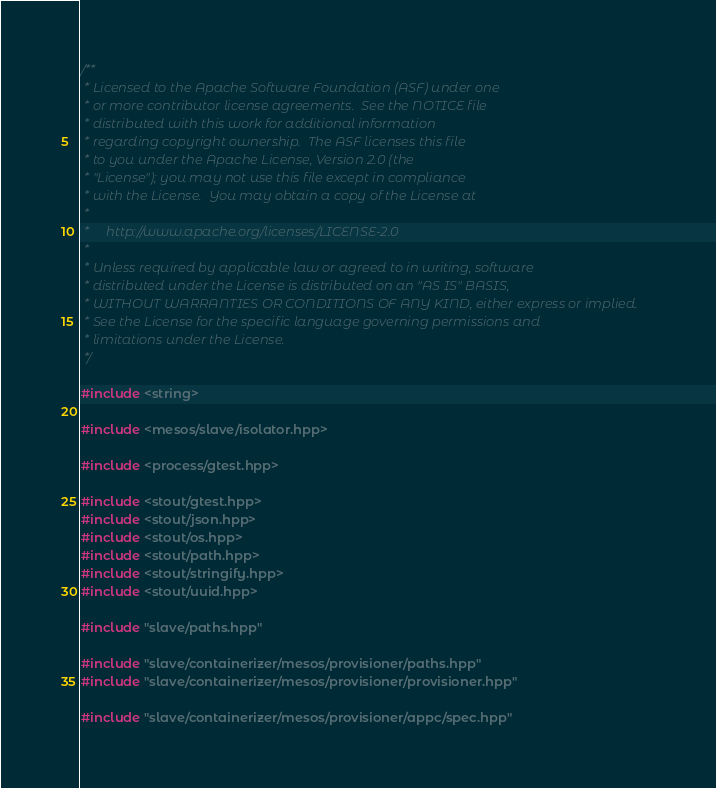<code> <loc_0><loc_0><loc_500><loc_500><_C++_>/**
 * Licensed to the Apache Software Foundation (ASF) under one
 * or more contributor license agreements.  See the NOTICE file
 * distributed with this work for additional information
 * regarding copyright ownership.  The ASF licenses this file
 * to you under the Apache License, Version 2.0 (the
 * "License"); you may not use this file except in compliance
 * with the License.  You may obtain a copy of the License at
 *
 *     http://www.apache.org/licenses/LICENSE-2.0
 *
 * Unless required by applicable law or agreed to in writing, software
 * distributed under the License is distributed on an "AS IS" BASIS,
 * WITHOUT WARRANTIES OR CONDITIONS OF ANY KIND, either express or implied.
 * See the License for the specific language governing permissions and
 * limitations under the License.
 */

#include <string>

#include <mesos/slave/isolator.hpp>

#include <process/gtest.hpp>

#include <stout/gtest.hpp>
#include <stout/json.hpp>
#include <stout/os.hpp>
#include <stout/path.hpp>
#include <stout/stringify.hpp>
#include <stout/uuid.hpp>

#include "slave/paths.hpp"

#include "slave/containerizer/mesos/provisioner/paths.hpp"
#include "slave/containerizer/mesos/provisioner/provisioner.hpp"

#include "slave/containerizer/mesos/provisioner/appc/spec.hpp"</code> 